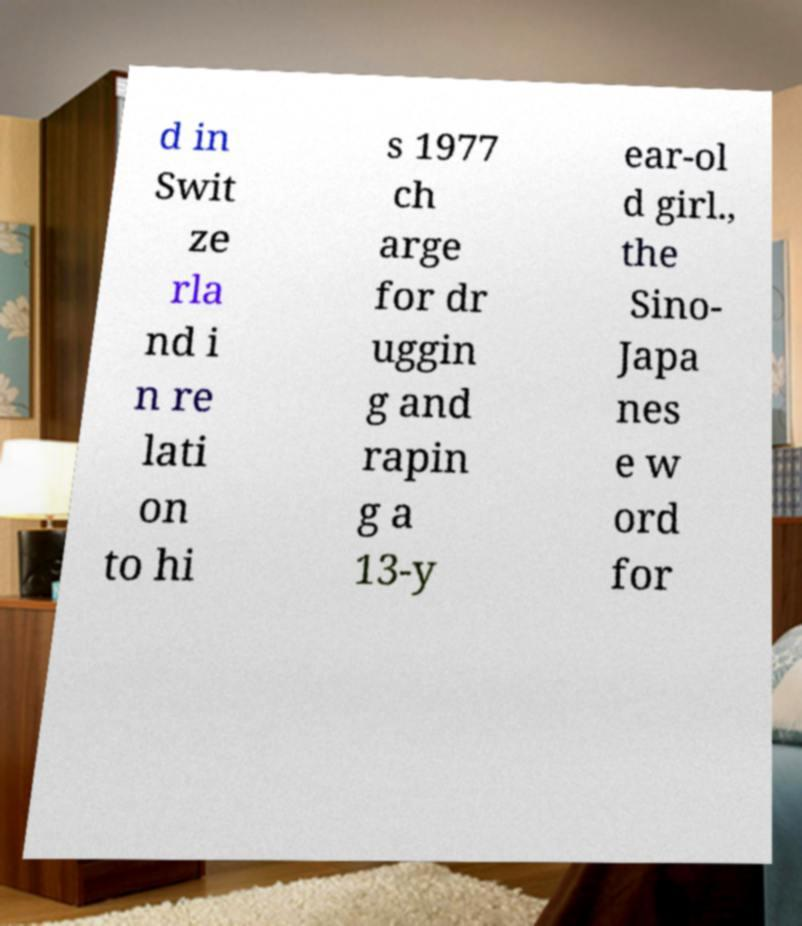Please read and relay the text visible in this image. What does it say? d in Swit ze rla nd i n re lati on to hi s 1977 ch arge for dr uggin g and rapin g a 13-y ear-ol d girl., the Sino- Japa nes e w ord for 